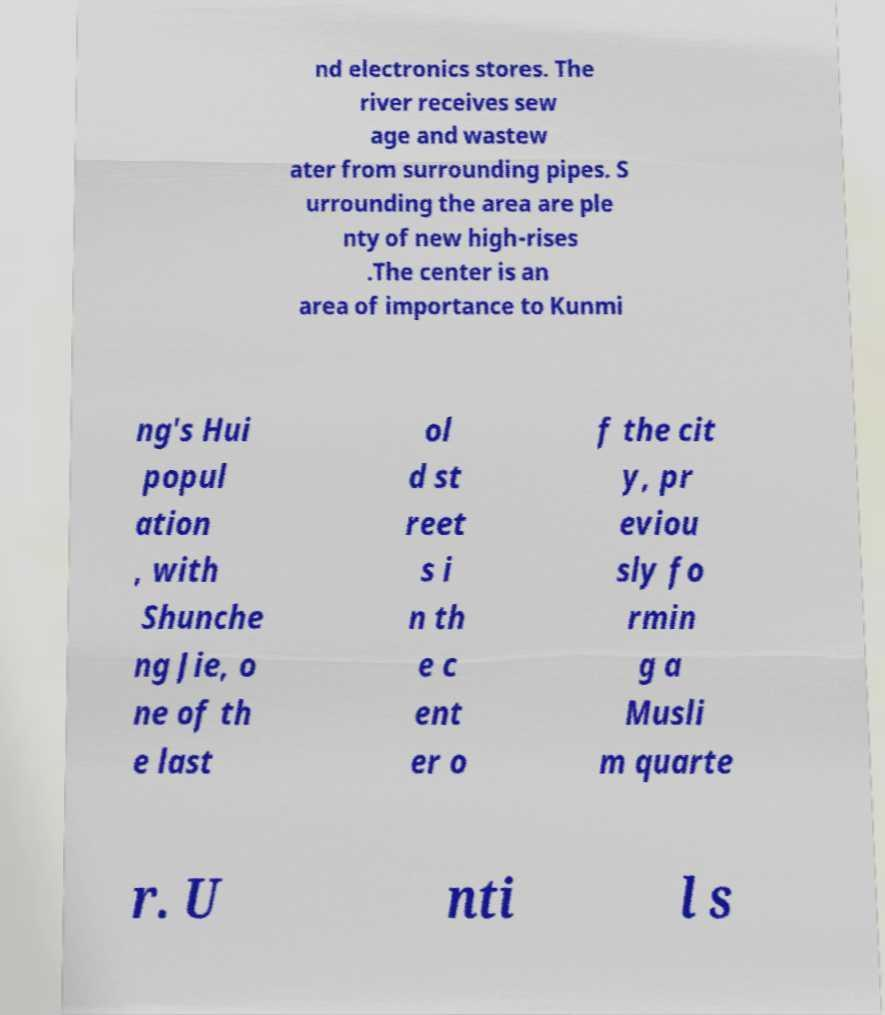Could you assist in decoding the text presented in this image and type it out clearly? nd electronics stores. The river receives sew age and wastew ater from surrounding pipes. S urrounding the area are ple nty of new high-rises .The center is an area of importance to Kunmi ng's Hui popul ation , with Shunche ng Jie, o ne of th e last ol d st reet s i n th e c ent er o f the cit y, pr eviou sly fo rmin g a Musli m quarte r. U nti l s 